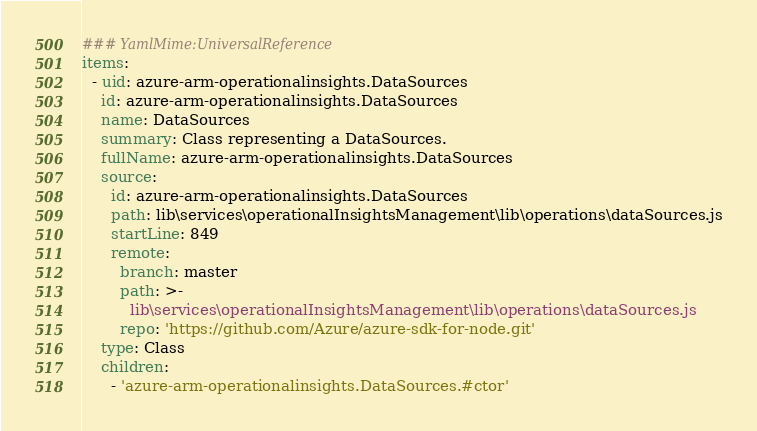<code> <loc_0><loc_0><loc_500><loc_500><_YAML_>### YamlMime:UniversalReference
items:
  - uid: azure-arm-operationalinsights.DataSources
    id: azure-arm-operationalinsights.DataSources
    name: DataSources
    summary: Class representing a DataSources.
    fullName: azure-arm-operationalinsights.DataSources
    source:
      id: azure-arm-operationalinsights.DataSources
      path: lib\services\operationalInsightsManagement\lib\operations\dataSources.js
      startLine: 849
      remote:
        branch: master
        path: >-
          lib\services\operationalInsightsManagement\lib\operations\dataSources.js
        repo: 'https://github.com/Azure/azure-sdk-for-node.git'
    type: Class
    children:
      - 'azure-arm-operationalinsights.DataSources.#ctor'</code> 